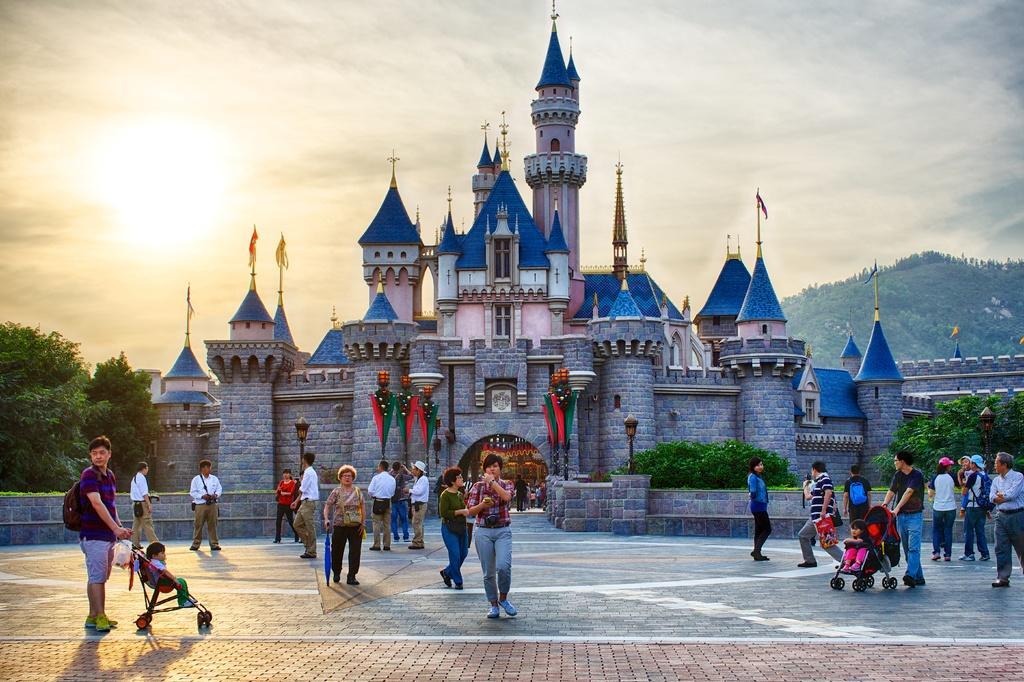Could you give a brief overview of what you see in this image? In this image there is a castle in the middle. In front of it there are so many people who are walking on the floor,while some people are standing. At the top there is the sky. There are trees on either side of the castle. On the left side there is a man who is holding the trolley in which there is a kid. 